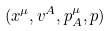<formula> <loc_0><loc_0><loc_500><loc_500>( x ^ { \mu } , v ^ { A } , p ^ { \mu } _ { A } , p )</formula> 